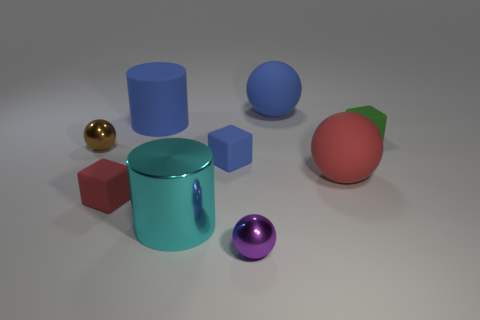Subtract 1 spheres. How many spheres are left? 3 Subtract all green spheres. Subtract all gray blocks. How many spheres are left? 4 Subtract all balls. How many objects are left? 5 Add 2 big red matte objects. How many big red matte objects exist? 3 Subtract 0 green cylinders. How many objects are left? 9 Subtract all small blue objects. Subtract all cubes. How many objects are left? 5 Add 8 purple things. How many purple things are left? 9 